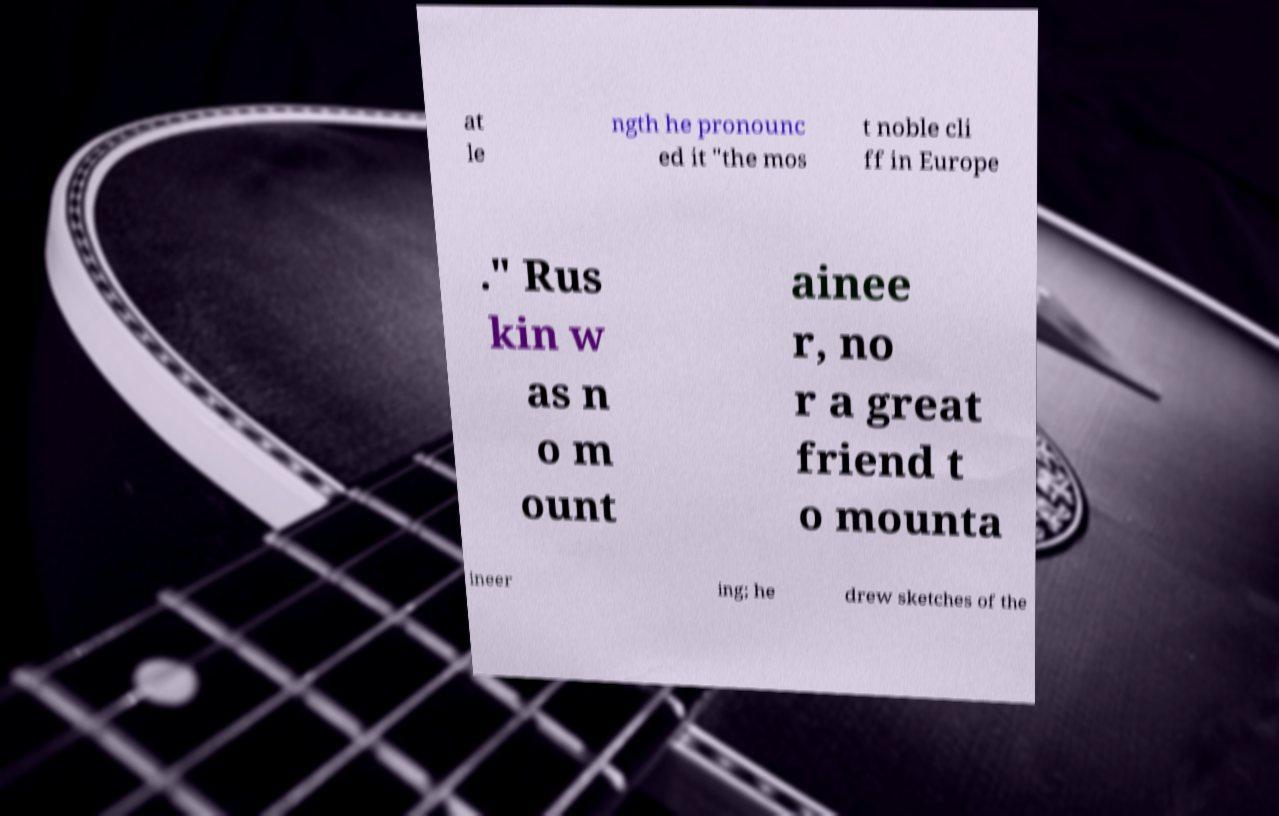I need the written content from this picture converted into text. Can you do that? at le ngth he pronounc ed it "the mos t noble cli ff in Europe ." Rus kin w as n o m ount ainee r, no r a great friend t o mounta ineer ing; he drew sketches of the 